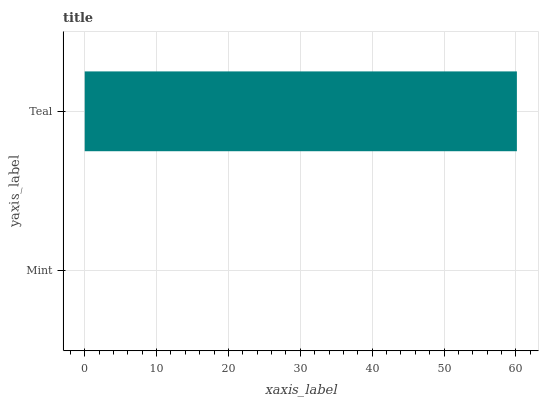Is Mint the minimum?
Answer yes or no. Yes. Is Teal the maximum?
Answer yes or no. Yes. Is Teal the minimum?
Answer yes or no. No. Is Teal greater than Mint?
Answer yes or no. Yes. Is Mint less than Teal?
Answer yes or no. Yes. Is Mint greater than Teal?
Answer yes or no. No. Is Teal less than Mint?
Answer yes or no. No. Is Teal the high median?
Answer yes or no. Yes. Is Mint the low median?
Answer yes or no. Yes. Is Mint the high median?
Answer yes or no. No. Is Teal the low median?
Answer yes or no. No. 